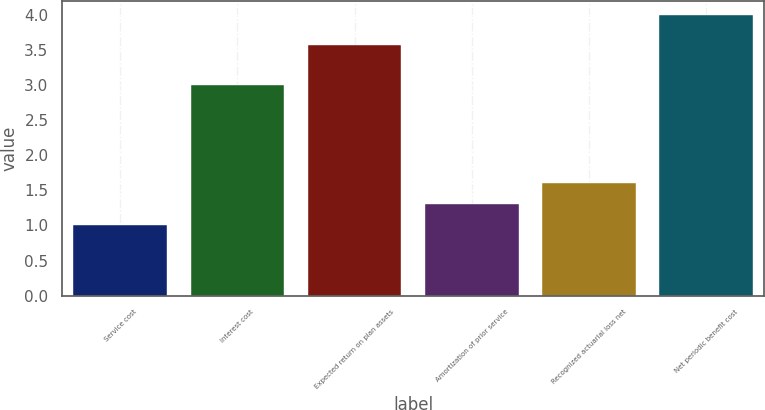<chart> <loc_0><loc_0><loc_500><loc_500><bar_chart><fcel>Service cost<fcel>Interest cost<fcel>Expected return on plan assets<fcel>Amortization of prior service<fcel>Recognized actuarial loss net<fcel>Net periodic benefit cost<nl><fcel>1<fcel>3<fcel>3.57<fcel>1.3<fcel>1.6<fcel>4<nl></chart> 